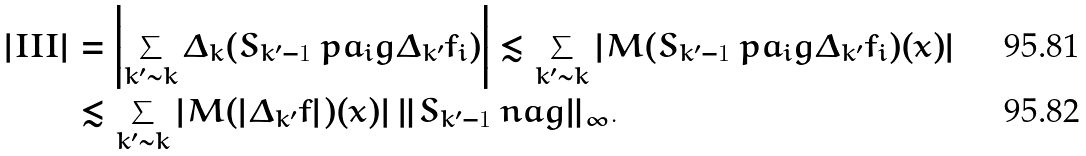Convert formula to latex. <formula><loc_0><loc_0><loc_500><loc_500>| I I I | & = \left | \sum _ { k ^ { \prime } \sim k } \Delta _ { k } ( S _ { k ^ { \prime } - 1 } { \ p a _ { i } g } \Delta _ { k ^ { \prime } } f _ { i } ) \right | \lesssim \sum _ { k ^ { \prime } \sim k } \left | M ( S _ { k ^ { \prime } - 1 } { \ p a _ { i } g } \Delta _ { k ^ { \prime } } f _ { i } ) ( x ) \right | \\ & \lesssim \sum _ { k ^ { \prime } \sim k } \left | M ( | \Delta _ { k ^ { \prime } } f | ) ( x ) \right | \| S _ { k ^ { \prime } - 1 } \ n a g \| _ { \infty } .</formula> 